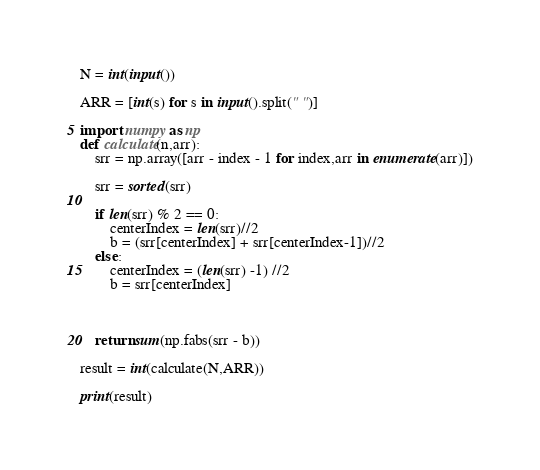Convert code to text. <code><loc_0><loc_0><loc_500><loc_500><_Python_>
N = int(input())

ARR = [int(s) for s in input().split(" ")]

import numpy as np
def calculate(n,arr):
    srr = np.array([arr - index - 1 for index,arr in enumerate(arr)])

    srr = sorted(srr)

    if len(srr) % 2 == 0:
        centerIndex = len(srr)//2
        b = (srr[centerIndex] + srr[centerIndex-1])//2
    else:
        centerIndex = (len(srr) -1) //2
        b = srr[centerIndex]



    return sum(np.fabs(srr - b))

result = int(calculate(N,ARR))

print(result)</code> 